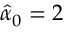<formula> <loc_0><loc_0><loc_500><loc_500>\hat { \alpha } _ { 0 } = 2</formula> 